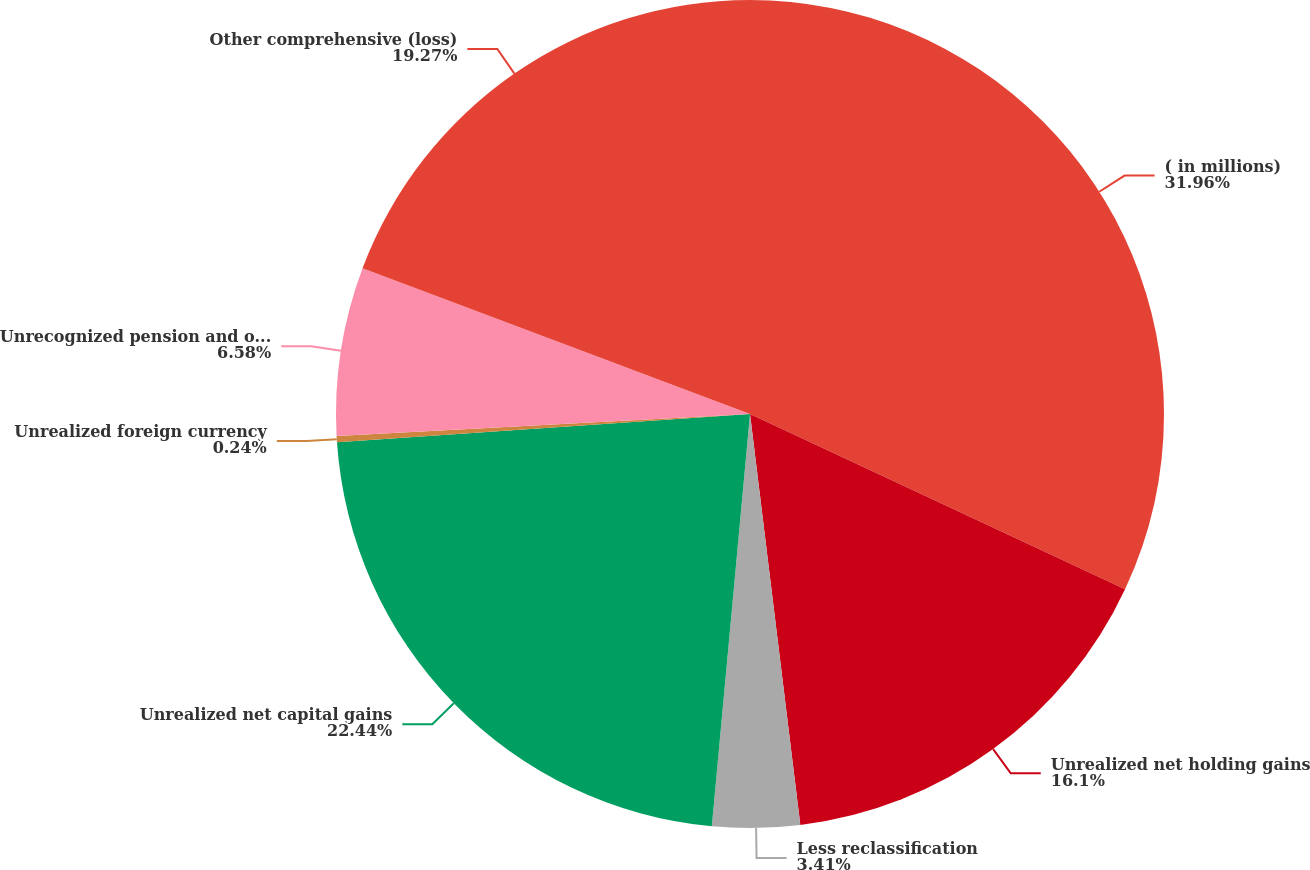<chart> <loc_0><loc_0><loc_500><loc_500><pie_chart><fcel>( in millions)<fcel>Unrealized net holding gains<fcel>Less reclassification<fcel>Unrealized net capital gains<fcel>Unrealized foreign currency<fcel>Unrecognized pension and other<fcel>Other comprehensive (loss)<nl><fcel>31.96%<fcel>16.1%<fcel>3.41%<fcel>22.44%<fcel>0.24%<fcel>6.58%<fcel>19.27%<nl></chart> 